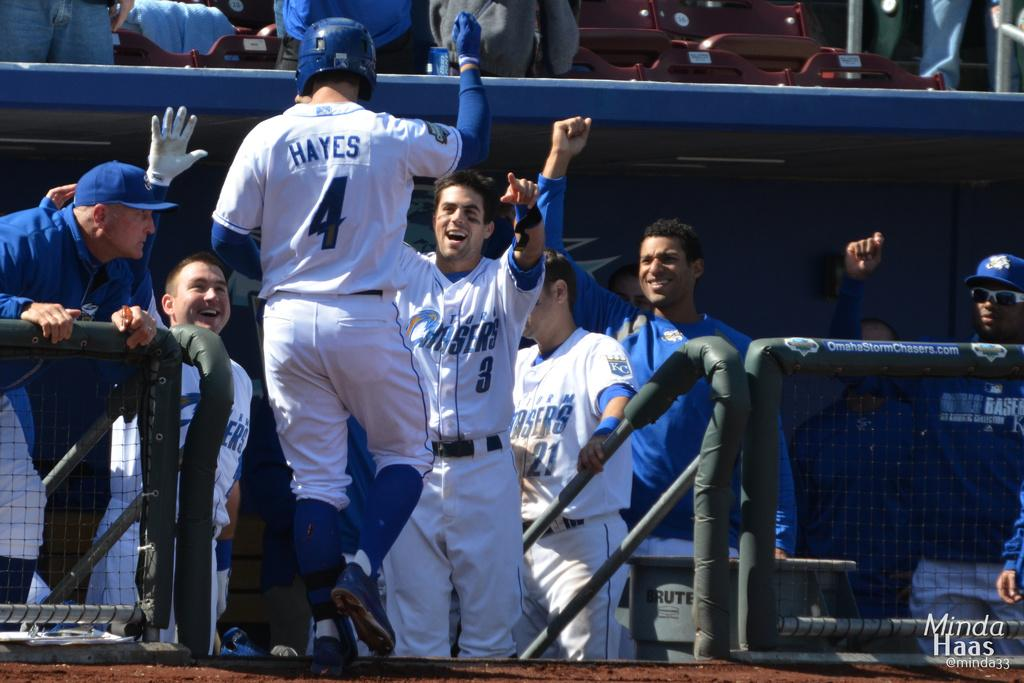<image>
Write a terse but informative summary of the picture. A guy is in a baseball uniform with the number 4 on it. 